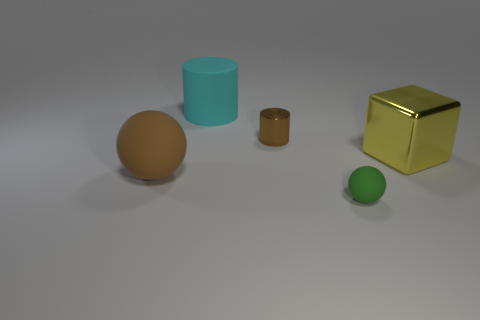What number of brown matte things are behind the small green thing?
Your response must be concise. 1. Is the metal cylinder the same color as the large matte cylinder?
Ensure brevity in your answer.  No. How many other big cubes have the same color as the large cube?
Offer a terse response. 0. Are there more tiny brown shiny things than yellow spheres?
Your answer should be very brief. Yes. What size is the rubber object that is behind the green ball and in front of the cyan matte cylinder?
Offer a terse response. Large. Do the object that is right of the green rubber thing and the ball that is to the right of the large matte cylinder have the same material?
Your answer should be very brief. No. There is a yellow metal object that is the same size as the cyan rubber object; what shape is it?
Your response must be concise. Cube. Are there fewer tiny brown things than blue metallic balls?
Give a very brief answer. No. Is there a brown matte object that is on the right side of the metal object that is to the right of the tiny brown thing?
Give a very brief answer. No. Are there any small green matte spheres that are to the right of the big matte thing right of the brown ball that is behind the green matte ball?
Your answer should be compact. Yes. 